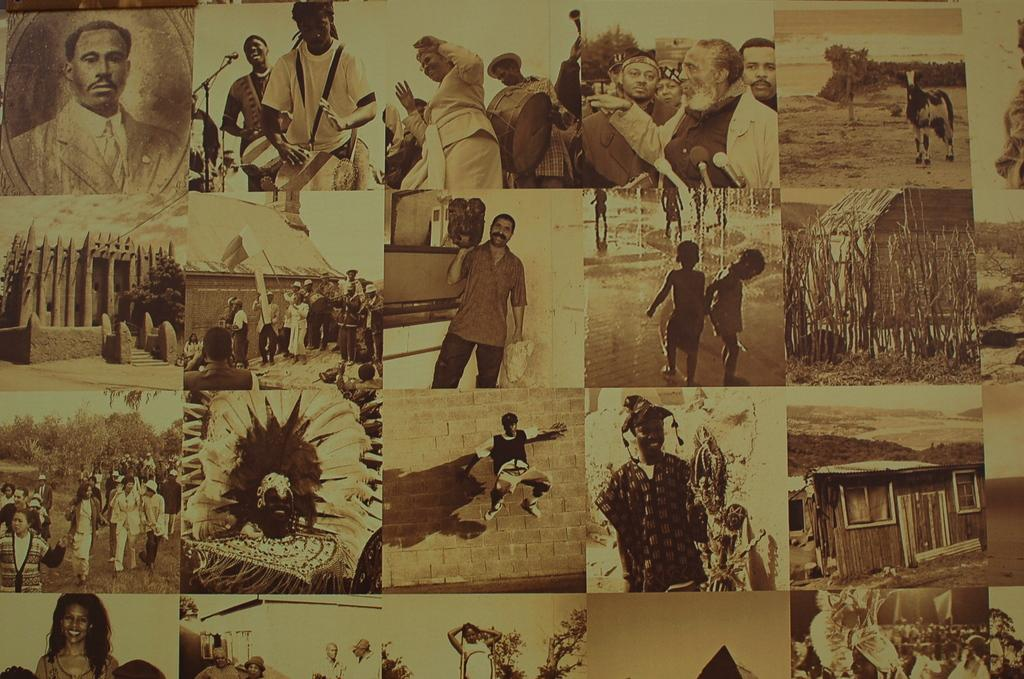What is the main subject of the image? The main subject of the image is multiple photographs. How are the photographs arranged in the image? The photographs are mixed up and kept at one place. What type of chalk is being used to draw on the photographs in the image? There is no chalk or drawing activity present in the image; it only features photographs that are mixed up and kept at one place. 